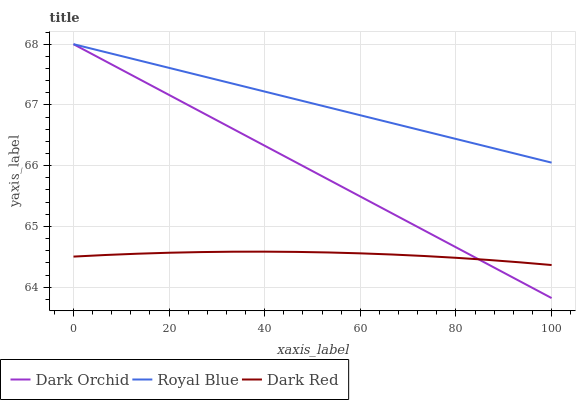Does Dark Red have the minimum area under the curve?
Answer yes or no. Yes. Does Royal Blue have the maximum area under the curve?
Answer yes or no. Yes. Does Dark Orchid have the minimum area under the curve?
Answer yes or no. No. Does Dark Orchid have the maximum area under the curve?
Answer yes or no. No. Is Dark Orchid the smoothest?
Answer yes or no. Yes. Is Dark Red the roughest?
Answer yes or no. Yes. Is Dark Red the smoothest?
Answer yes or no. No. Is Dark Orchid the roughest?
Answer yes or no. No. Does Dark Orchid have the lowest value?
Answer yes or no. Yes. Does Dark Red have the lowest value?
Answer yes or no. No. Does Dark Orchid have the highest value?
Answer yes or no. Yes. Does Dark Red have the highest value?
Answer yes or no. No. Is Dark Red less than Royal Blue?
Answer yes or no. Yes. Is Royal Blue greater than Dark Red?
Answer yes or no. Yes. Does Royal Blue intersect Dark Orchid?
Answer yes or no. Yes. Is Royal Blue less than Dark Orchid?
Answer yes or no. No. Is Royal Blue greater than Dark Orchid?
Answer yes or no. No. Does Dark Red intersect Royal Blue?
Answer yes or no. No. 